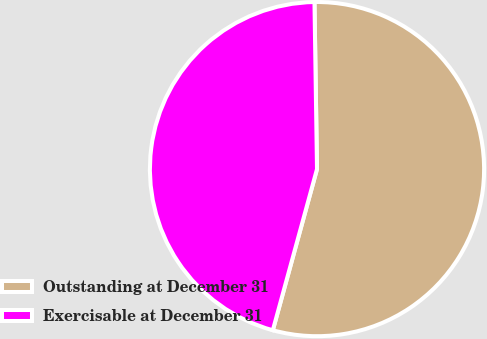<chart> <loc_0><loc_0><loc_500><loc_500><pie_chart><fcel>Outstanding at December 31<fcel>Exercisable at December 31<nl><fcel>54.5%<fcel>45.5%<nl></chart> 